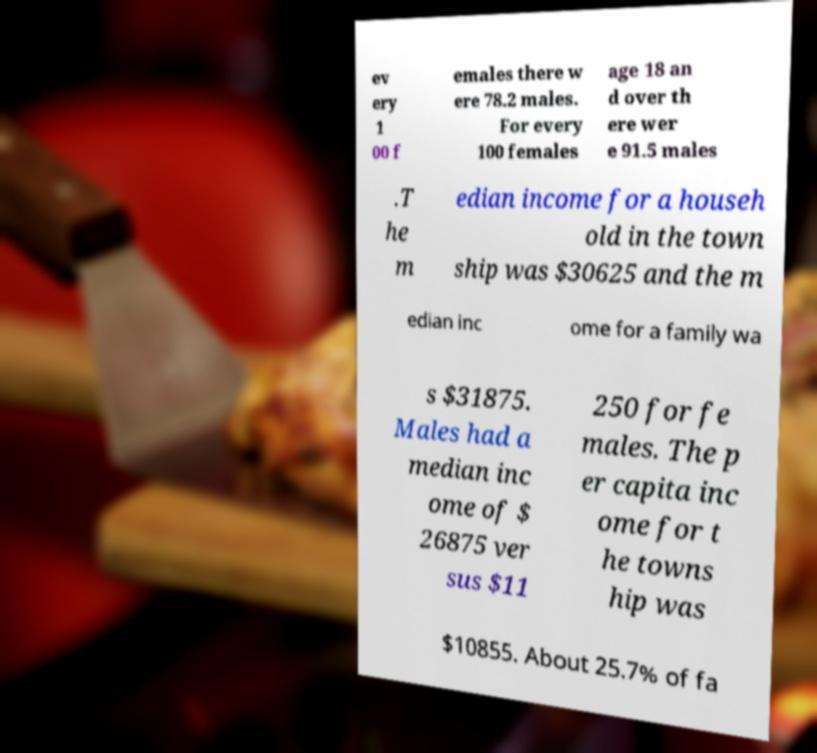Please read and relay the text visible in this image. What does it say? ev ery 1 00 f emales there w ere 78.2 males. For every 100 females age 18 an d over th ere wer e 91.5 males .T he m edian income for a househ old in the town ship was $30625 and the m edian inc ome for a family wa s $31875. Males had a median inc ome of $ 26875 ver sus $11 250 for fe males. The p er capita inc ome for t he towns hip was $10855. About 25.7% of fa 